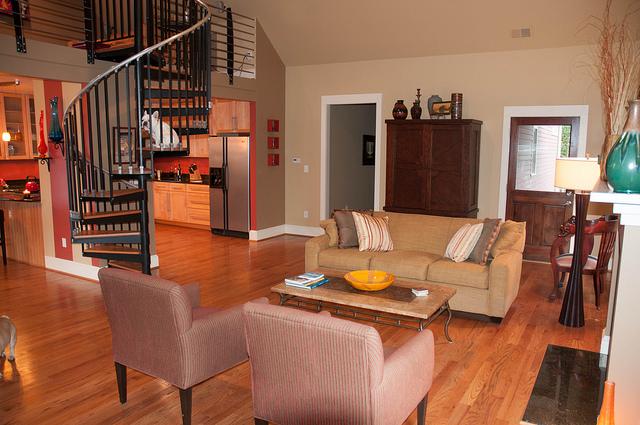What animal is sitting on the stairs?
Quick response, please. Dog. What breed of dog is in this photo?
Answer briefly. French bulldog. Could this be described as spacious?
Short answer required. Yes. How many chairs are seen?
Give a very brief answer. 3. What is between the chair and table?
Answer briefly. Floor. 